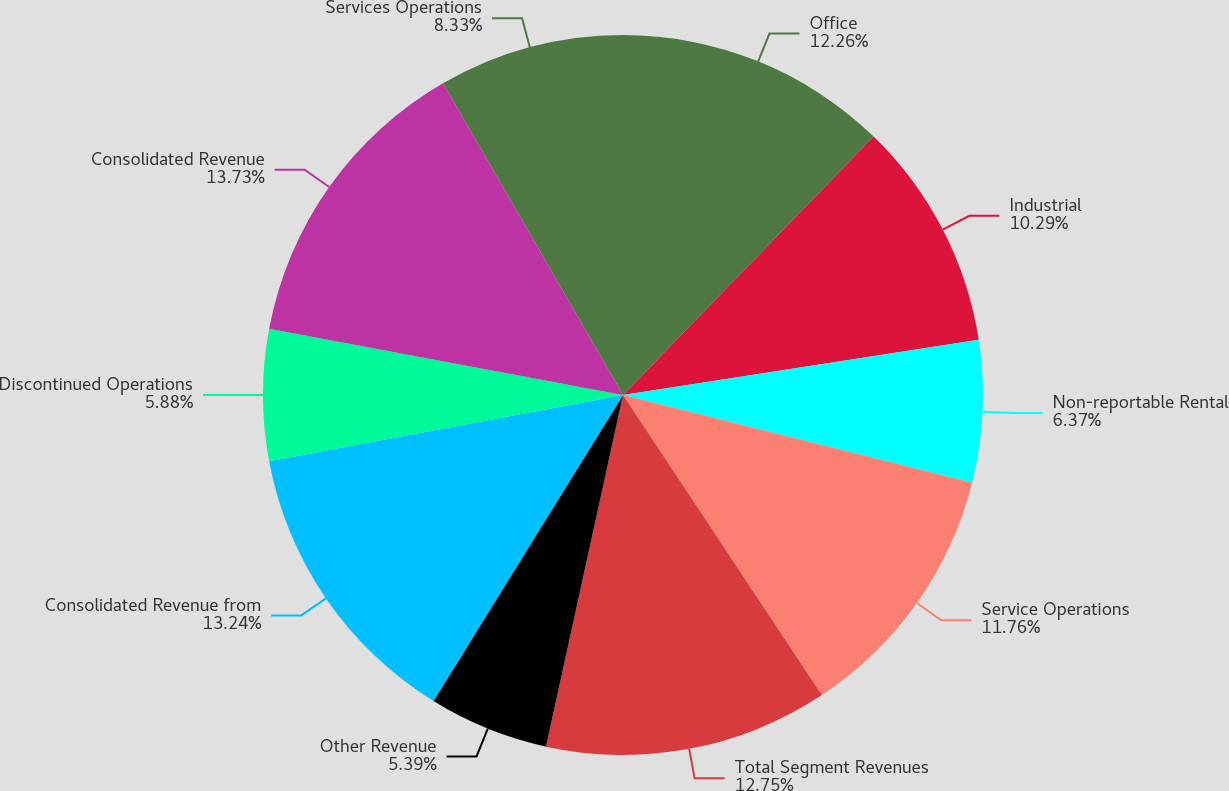<chart> <loc_0><loc_0><loc_500><loc_500><pie_chart><fcel>Office<fcel>Industrial<fcel>Non-reportable Rental<fcel>Service Operations<fcel>Total Segment Revenues<fcel>Other Revenue<fcel>Consolidated Revenue from<fcel>Discontinued Operations<fcel>Consolidated Revenue<fcel>Services Operations<nl><fcel>12.25%<fcel>10.29%<fcel>6.37%<fcel>11.76%<fcel>12.74%<fcel>5.39%<fcel>13.23%<fcel>5.88%<fcel>13.72%<fcel>8.33%<nl></chart> 